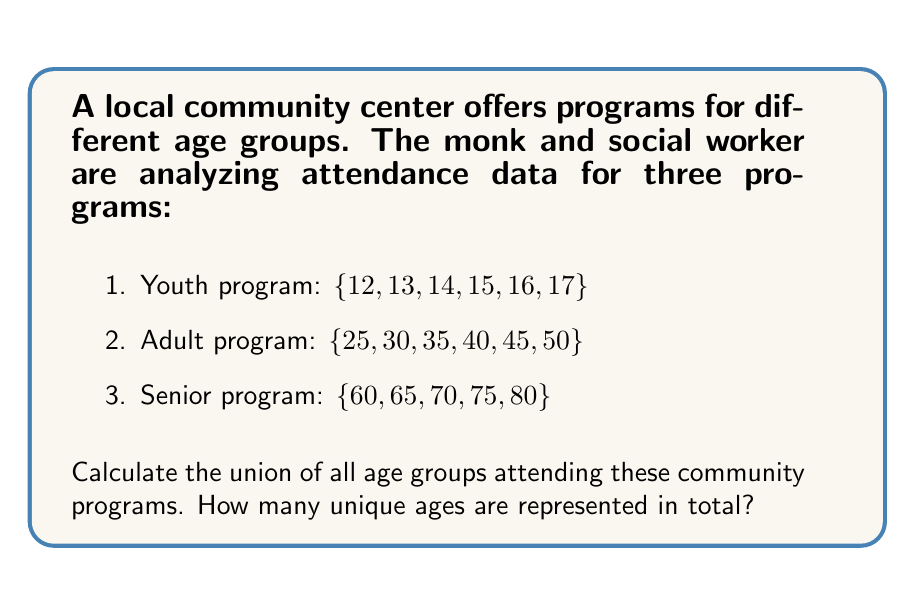Could you help me with this problem? To solve this problem, we need to find the union of the three sets representing the age groups for each program. Let's approach this step-by-step:

1. Define our sets:
   Let A = Youth program = $\{12, 13, 14, 15, 16, 17\}$
   Let B = Adult program = $\{25, 30, 35, 40, 45, 50\}$
   Let C = Senior program = $\{60, 65, 70, 75, 80\}$

2. We need to find $A \cup B \cup C$, which represents all unique elements in these sets.

3. To do this, we can list all unique elements from all sets:
   $A \cup B \cup C = \{12, 13, 14, 15, 16, 17, 25, 30, 35, 40, 45, 50, 60, 65, 70, 75, 80\}$

4. Now, we simply need to count the number of elements in this union.

5. Counting the elements, we get 17 unique ages.

This method works because the sets are already disjoint (they don't share any common elements), so we don't need to worry about removing duplicates.
Answer: The union of all age groups contains 17 unique ages. 